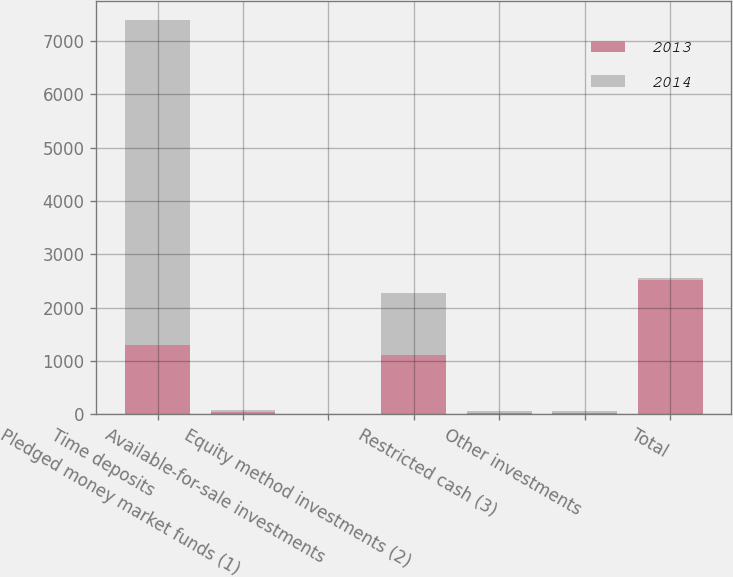<chart> <loc_0><loc_0><loc_500><loc_500><stacked_bar_chart><ecel><fcel>Time deposits<fcel>Pledged money market funds (1)<fcel>Available-for-sale investments<fcel>Equity method investments (2)<fcel>Restricted cash (3)<fcel>Other investments<fcel>Total<nl><fcel>2013<fcel>1295<fcel>38<fcel>7<fcel>1114<fcel>26<fcel>33<fcel>2513<nl><fcel>2014<fcel>6090<fcel>46<fcel>8<fcel>1164<fcel>33<fcel>33<fcel>38<nl></chart> 